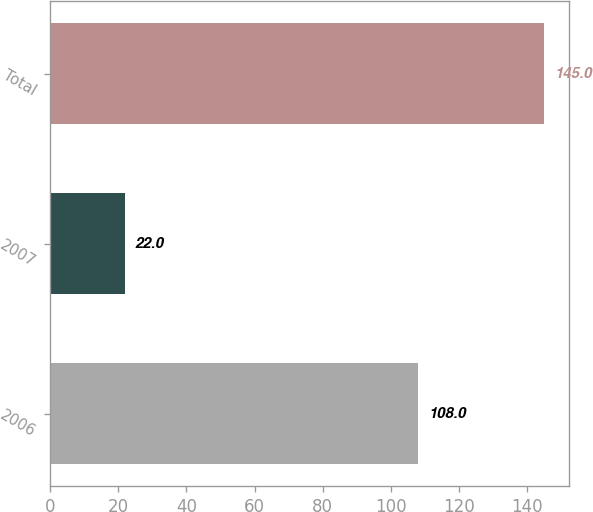Convert chart. <chart><loc_0><loc_0><loc_500><loc_500><bar_chart><fcel>2006<fcel>2007<fcel>Total<nl><fcel>108<fcel>22<fcel>145<nl></chart> 